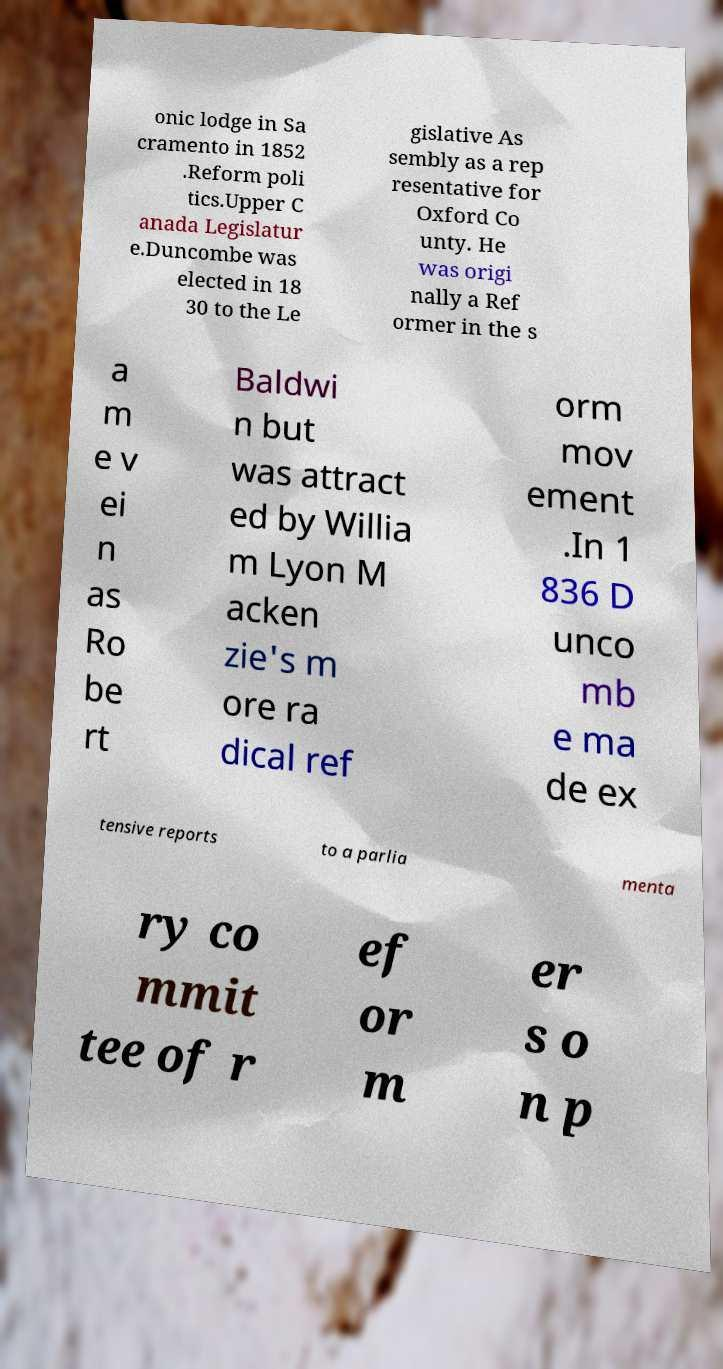Please identify and transcribe the text found in this image. onic lodge in Sa cramento in 1852 .Reform poli tics.Upper C anada Legislatur e.Duncombe was elected in 18 30 to the Le gislative As sembly as a rep resentative for Oxford Co unty. He was origi nally a Ref ormer in the s a m e v ei n as Ro be rt Baldwi n but was attract ed by Willia m Lyon M acken zie's m ore ra dical ref orm mov ement .In 1 836 D unco mb e ma de ex tensive reports to a parlia menta ry co mmit tee of r ef or m er s o n p 